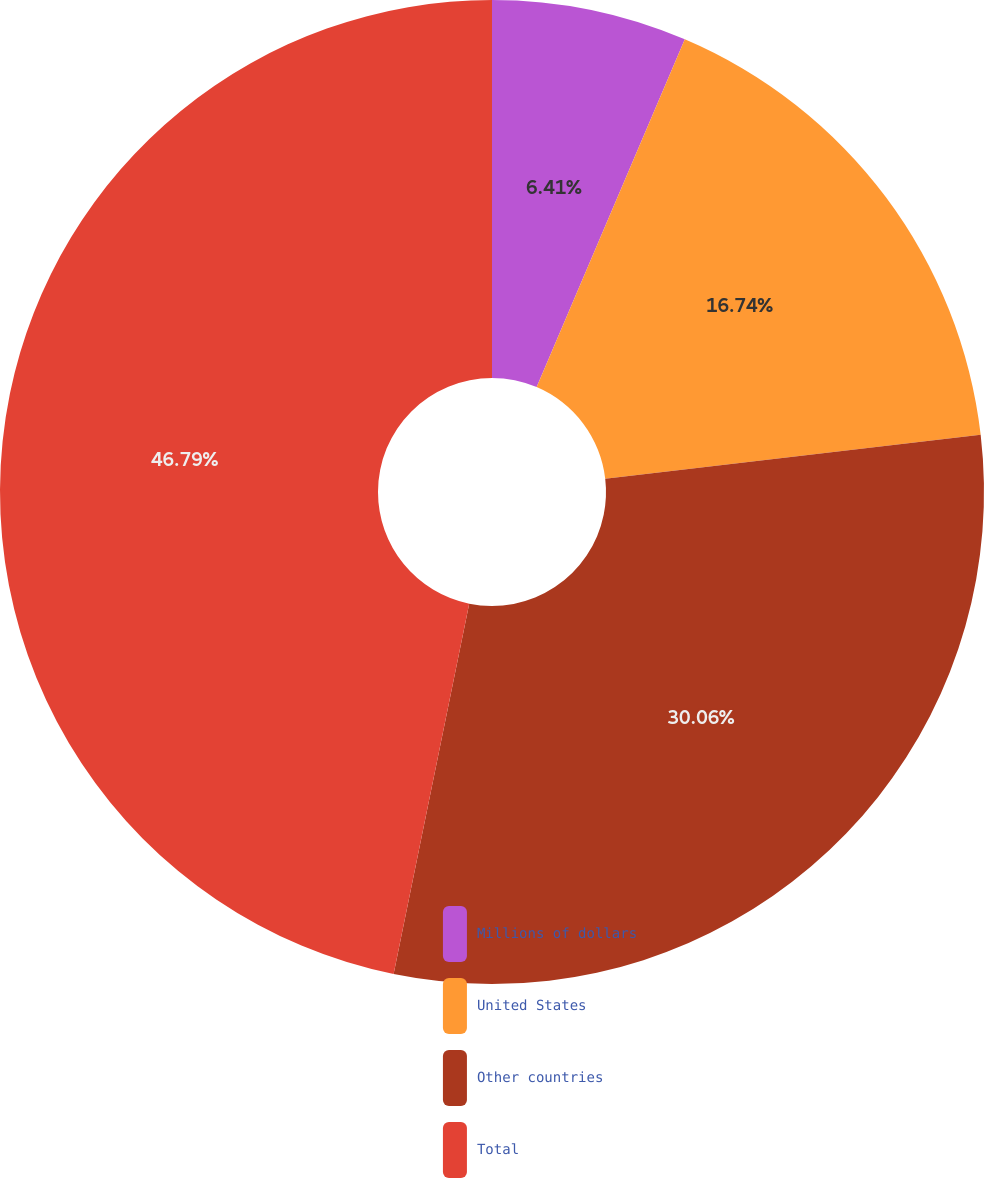Convert chart to OTSL. <chart><loc_0><loc_0><loc_500><loc_500><pie_chart><fcel>Millions of dollars<fcel>United States<fcel>Other countries<fcel>Total<nl><fcel>6.41%<fcel>16.74%<fcel>30.06%<fcel>46.8%<nl></chart> 